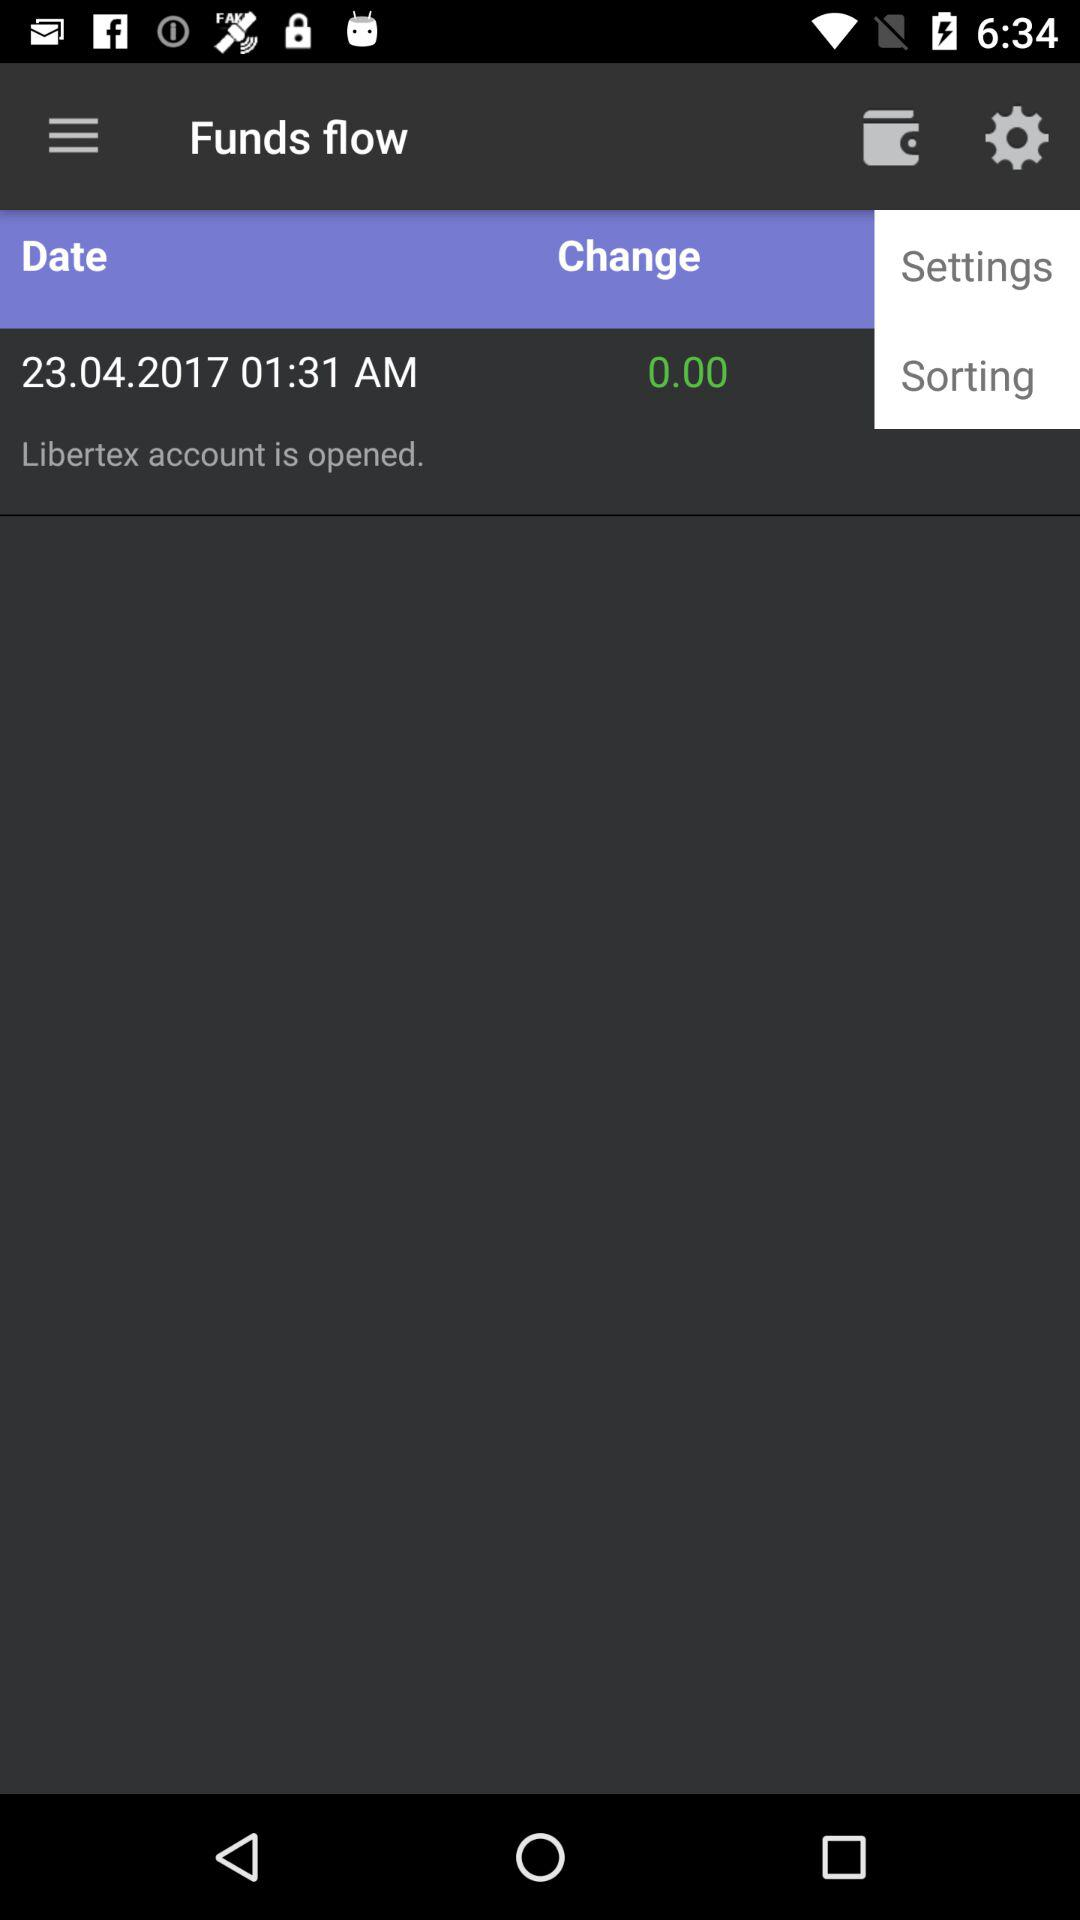When was the "Libertex" account opened? The "Libertex" account was opened on April 23, 2017 at 1:31 AM. 